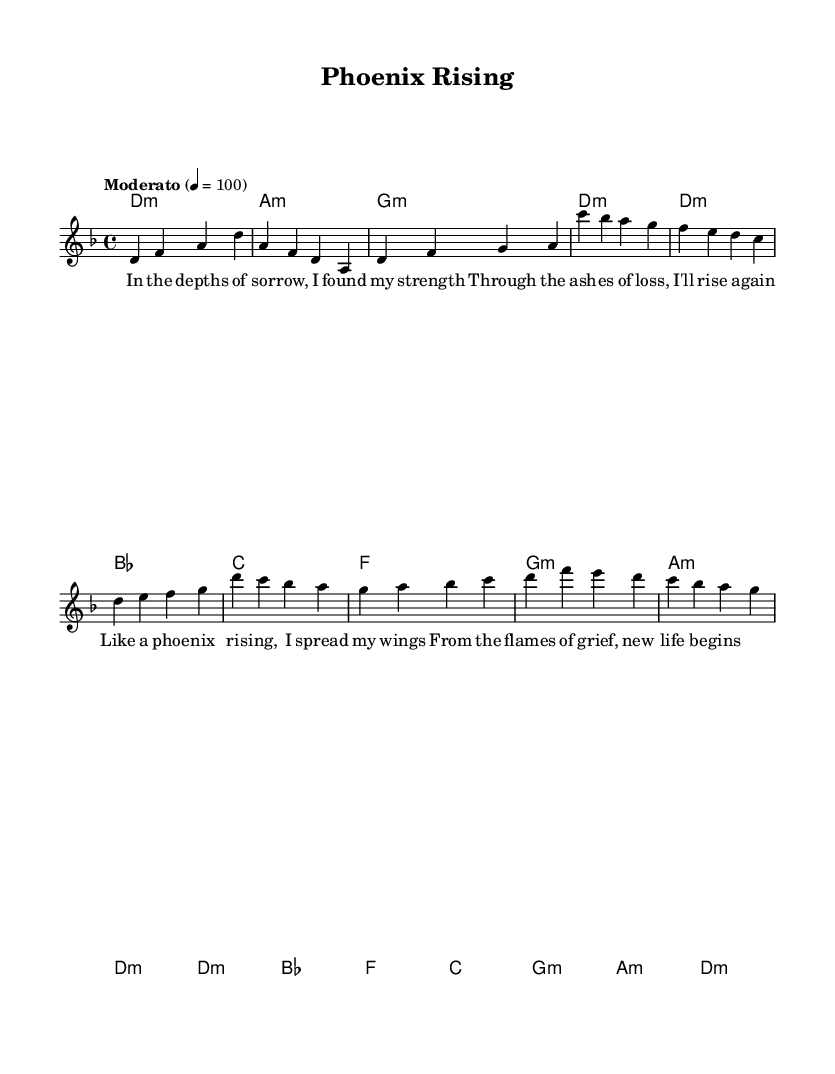What is the key signature of this music? The key signature is marked by the presence of an B flat. The music is in D minor, which has one flat.
Answer: D minor What is the time signature of this music? The time signature is located at the beginning of the sheet music, represented as a fraction. Here, it shows 4 beats in each measure (top number) and the quarter note gets the beat (bottom number).
Answer: 4/4 What is the tempo of this piece? The tempo marking is indicated at the beginning of the score with the word "Moderato" along with the beats per minute, which is 100.
Answer: Moderato 100 How many measures are in the chorus section of the song? By analyzing the score, the chorus consists of four lines in the melody and six chords, indicating a total of four measures. Each line corresponds to a single musical phrase denoted by the measure bar lines.
Answer: Four What emotion does the title "Phoenix Rising" convey in relation to the music? The title suggests themes of renewal and resilience, symbolized by the mythical phoenix that rises from its ashes. This is reinforced by the lyrics that describe overcoming sorrow and finding strength, merging the concept of healing with the metal genre's dramatic style.
Answer: Resilience What chord is used in the first measure of the verse? The first measure of the verse displays a D minor chord, shown by the chord markings above the staff. Chord symbols denote the harmonic structure supporting the melody.
Answer: D minor What type of lyrical theme is present in "Phoenix Rising"? The lyrics reflect a theme of resilience and healing, depicting personal strength in times of grief. The phrasing indicates a journey from loss to recovery, representative of the overall emotional essence present in this symphonic metal composition.
Answer: Resilience and healing 